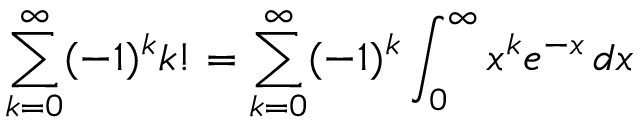Convert formula to latex. <formula><loc_0><loc_0><loc_500><loc_500>\sum _ { k = 0 } ^ { \infty } ( - 1 ) ^ { k } k ! = \sum _ { k = 0 } ^ { \infty } ( - 1 ) ^ { k } \int _ { 0 } ^ { \infty } x ^ { k } e ^ { - x } \, d x</formula> 